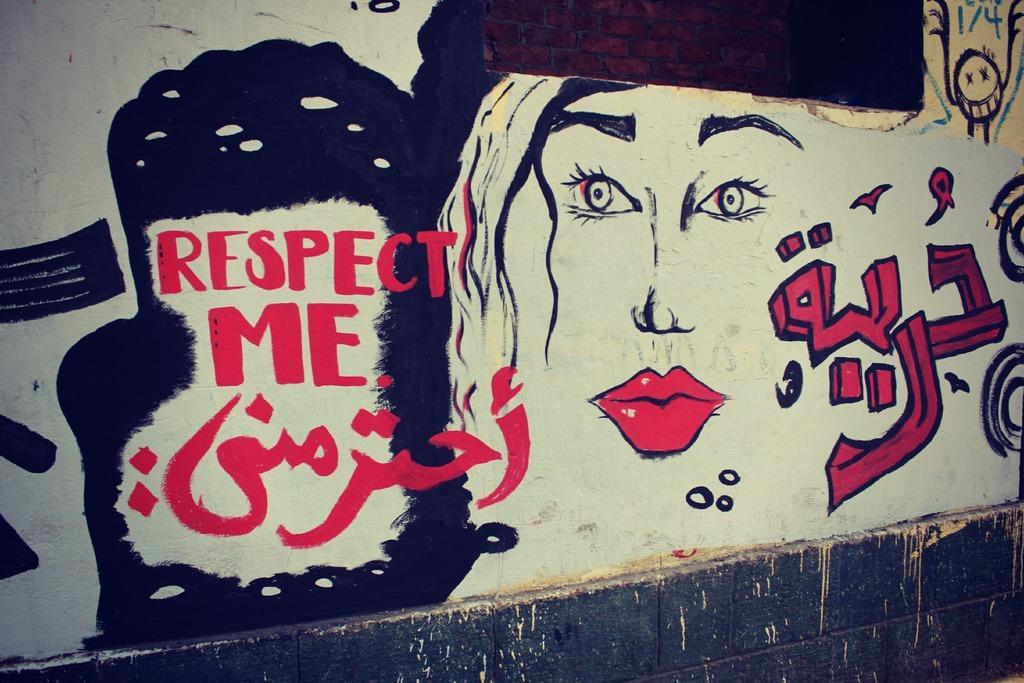Please provide a concise description of this image. In this image there is a painting and there is some text on the wall. 